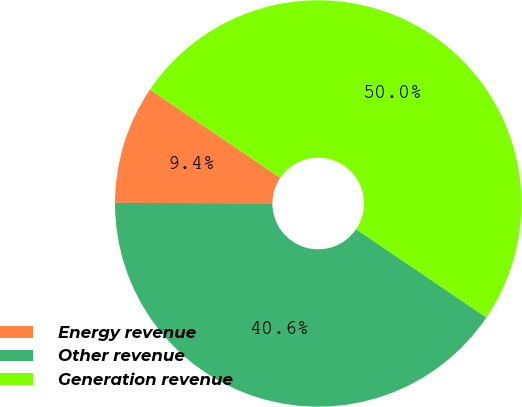<chart> <loc_0><loc_0><loc_500><loc_500><pie_chart><fcel>Energy revenue<fcel>Other revenue<fcel>Generation revenue<nl><fcel>9.43%<fcel>40.57%<fcel>50.0%<nl></chart> 